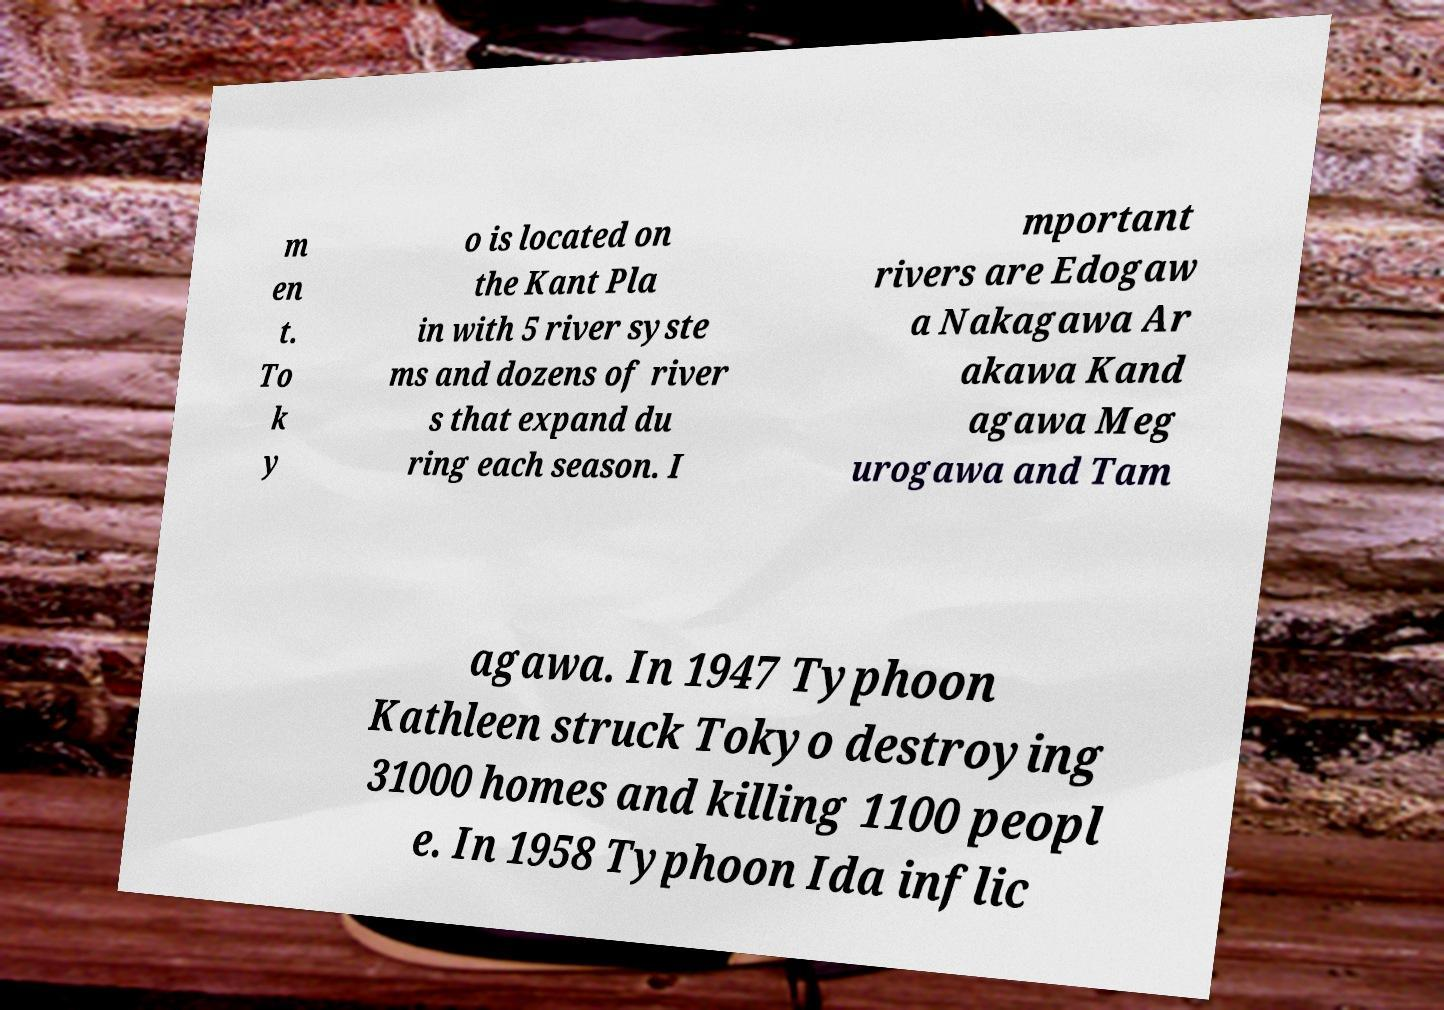Please identify and transcribe the text found in this image. m en t. To k y o is located on the Kant Pla in with 5 river syste ms and dozens of river s that expand du ring each season. I mportant rivers are Edogaw a Nakagawa Ar akawa Kand agawa Meg urogawa and Tam agawa. In 1947 Typhoon Kathleen struck Tokyo destroying 31000 homes and killing 1100 peopl e. In 1958 Typhoon Ida inflic 